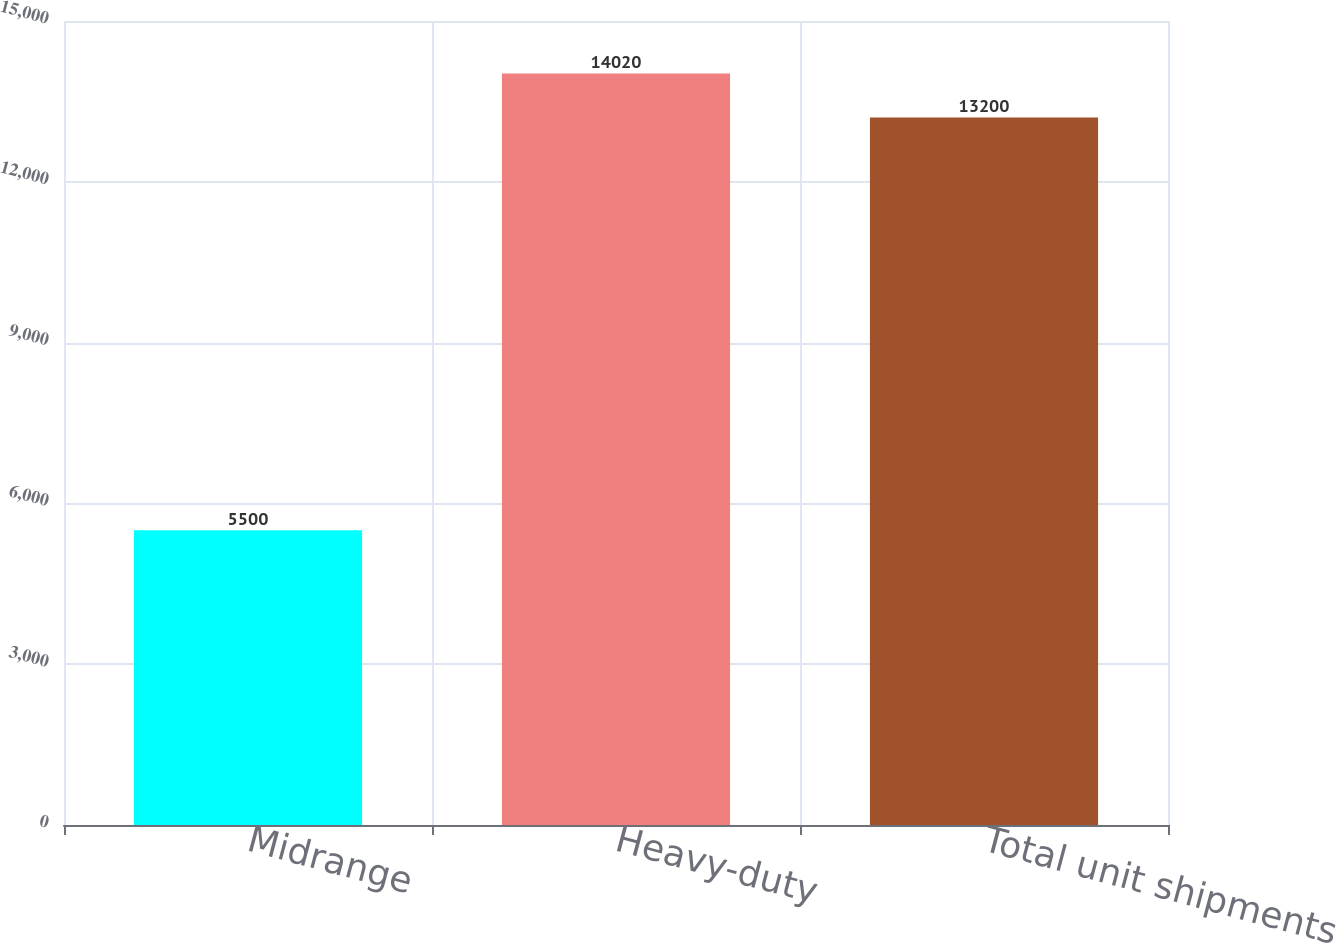Convert chart to OTSL. <chart><loc_0><loc_0><loc_500><loc_500><bar_chart><fcel>Midrange<fcel>Heavy-duty<fcel>Total unit shipments<nl><fcel>5500<fcel>14020<fcel>13200<nl></chart> 